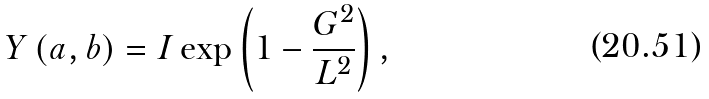<formula> <loc_0><loc_0><loc_500><loc_500>Y \left ( a , b \right ) = I \exp \left ( 1 - \frac { G ^ { 2 } } { L ^ { 2 } } \right ) ,</formula> 